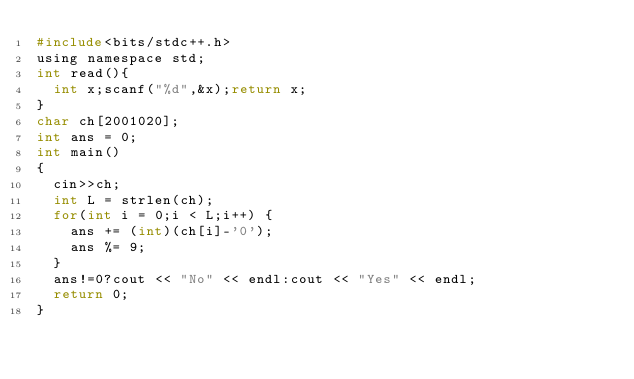<code> <loc_0><loc_0><loc_500><loc_500><_C_>#include<bits/stdc++.h>
using namespace std;
int read(){
	int x;scanf("%d",&x);return x;
}
char ch[2001020];
int ans = 0;
int main()
{
	cin>>ch;
	int L = strlen(ch);
	for(int i = 0;i < L;i++) {
		ans += (int)(ch[i]-'0');
		ans %= 9;
	}
	ans!=0?cout << "No" << endl:cout << "Yes" << endl;
	return 0;
}</code> 